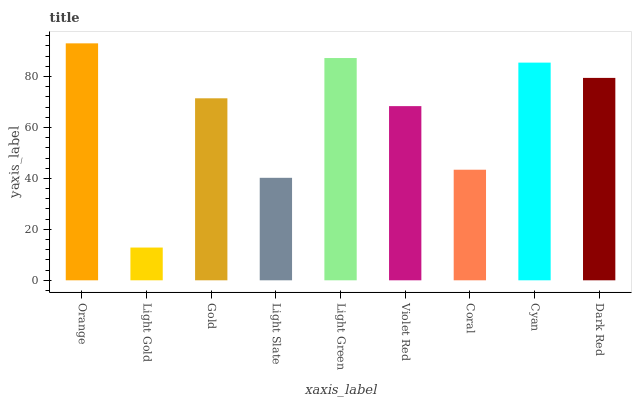Is Light Gold the minimum?
Answer yes or no. Yes. Is Orange the maximum?
Answer yes or no. Yes. Is Gold the minimum?
Answer yes or no. No. Is Gold the maximum?
Answer yes or no. No. Is Gold greater than Light Gold?
Answer yes or no. Yes. Is Light Gold less than Gold?
Answer yes or no. Yes. Is Light Gold greater than Gold?
Answer yes or no. No. Is Gold less than Light Gold?
Answer yes or no. No. Is Gold the high median?
Answer yes or no. Yes. Is Gold the low median?
Answer yes or no. Yes. Is Orange the high median?
Answer yes or no. No. Is Orange the low median?
Answer yes or no. No. 